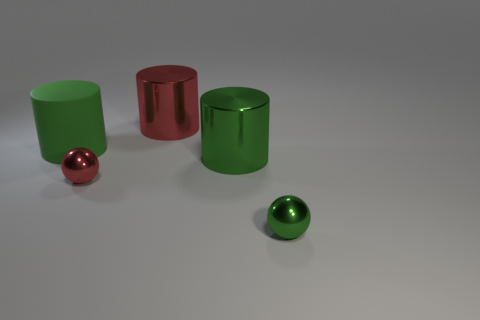Is the red cylinder the same size as the matte thing?
Provide a short and direct response. Yes. What number of things are either large red metallic objects or metallic objects left of the small green sphere?
Provide a short and direct response. 3. What is the material of the tiny green thing?
Provide a succinct answer. Metal. Is there any other thing that has the same color as the big rubber cylinder?
Make the answer very short. Yes. Does the big green shiny thing have the same shape as the big red thing?
Your answer should be compact. Yes. There is a object in front of the tiny metal sphere that is to the left of the cylinder in front of the green matte cylinder; what is its size?
Keep it short and to the point. Small. What number of other things are there of the same material as the tiny red sphere
Make the answer very short. 3. There is a small sphere that is on the right side of the red cylinder; what is its color?
Offer a terse response. Green. There is a big thing that is in front of the green thing on the left side of the big green metallic cylinder on the right side of the big red metal cylinder; what is it made of?
Ensure brevity in your answer.  Metal. Is there another large rubber object of the same shape as the large red object?
Make the answer very short. Yes. 